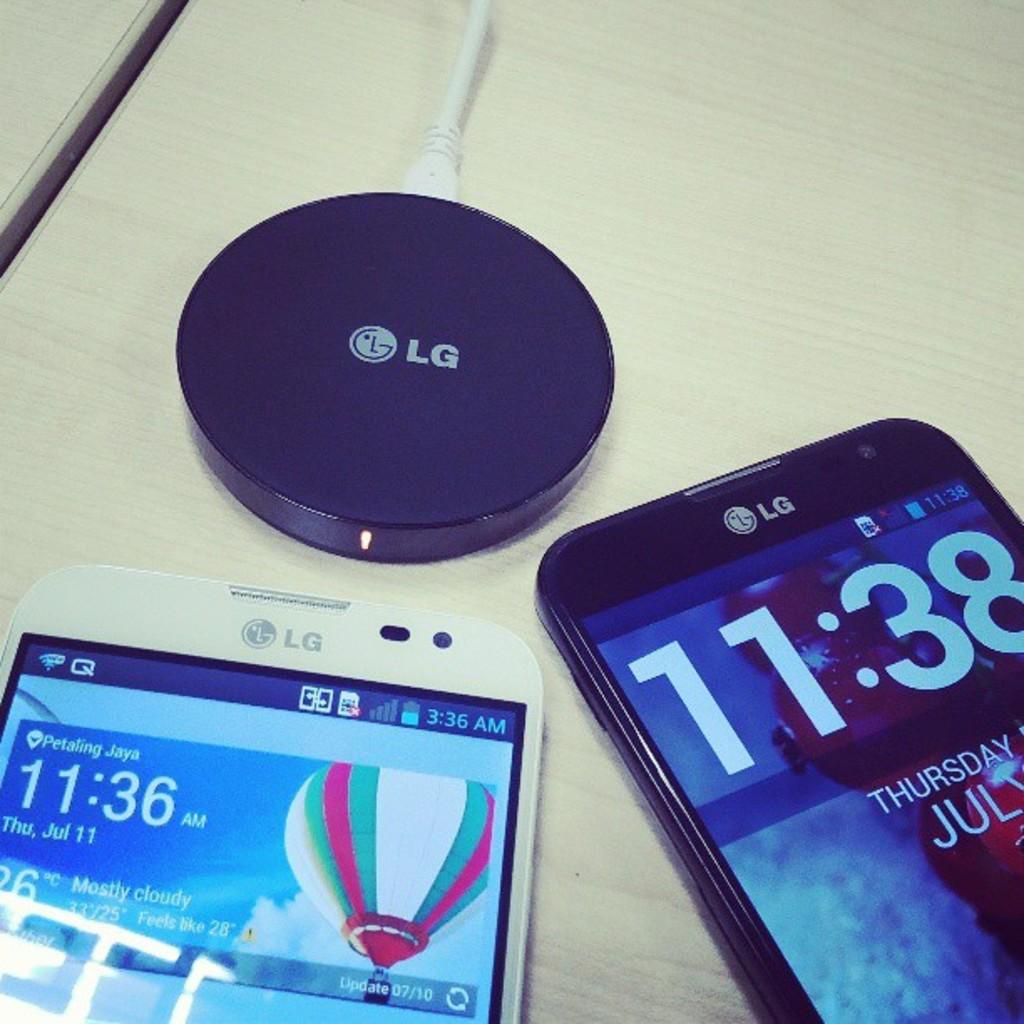What brand are these devices?
Offer a terse response. Lg. What time is it on the cell phone on the right?
Make the answer very short. 11:38. 